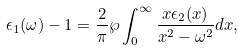Convert formula to latex. <formula><loc_0><loc_0><loc_500><loc_500>\epsilon _ { 1 } ( \omega ) - 1 = \frac { 2 } { \pi } \wp \int _ { 0 } ^ { \infty } \frac { x \epsilon _ { 2 } ( x ) } { x ^ { 2 } - \omega ^ { 2 } } d x ,</formula> 